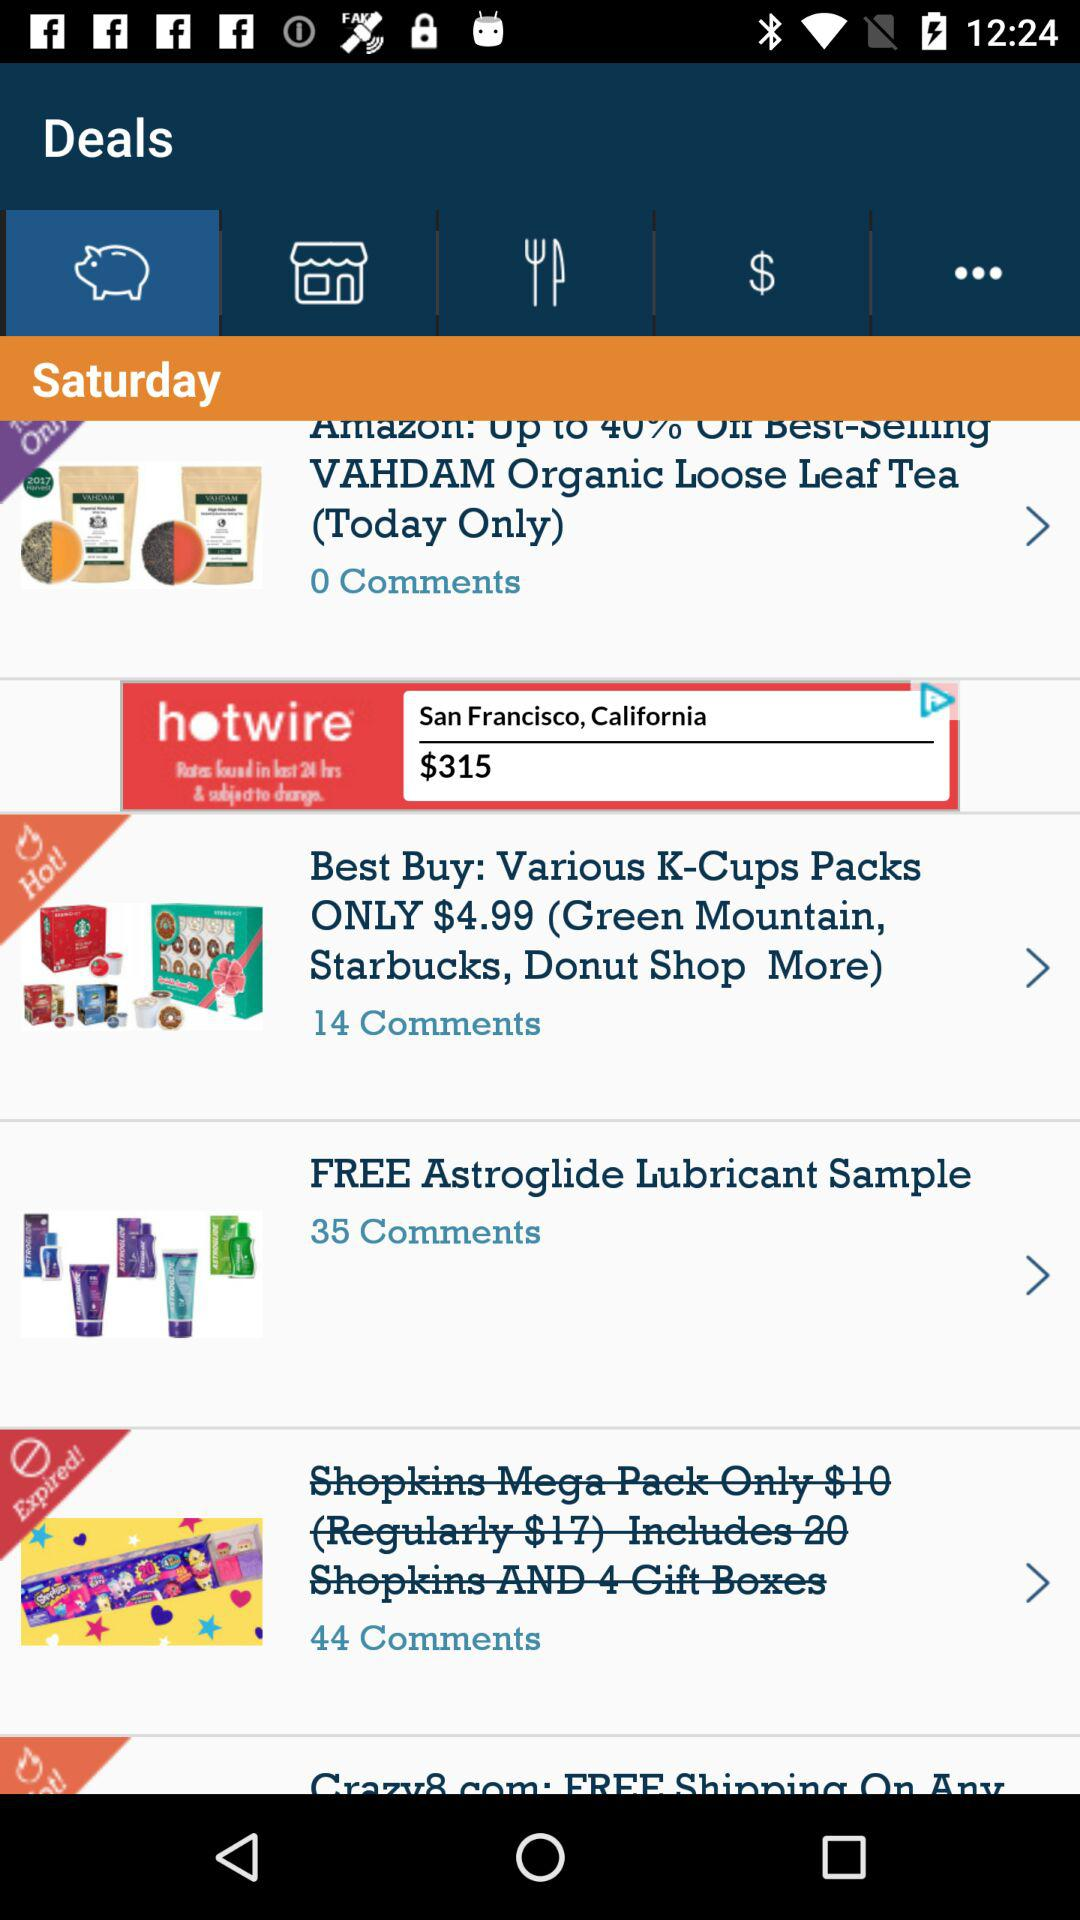Which of these is a hot deal? The hot deal is "Best Buy: Various K-Cups Packs ONLY $4.99 (Green Mountain, Starbucks, Donut Shop More)". 